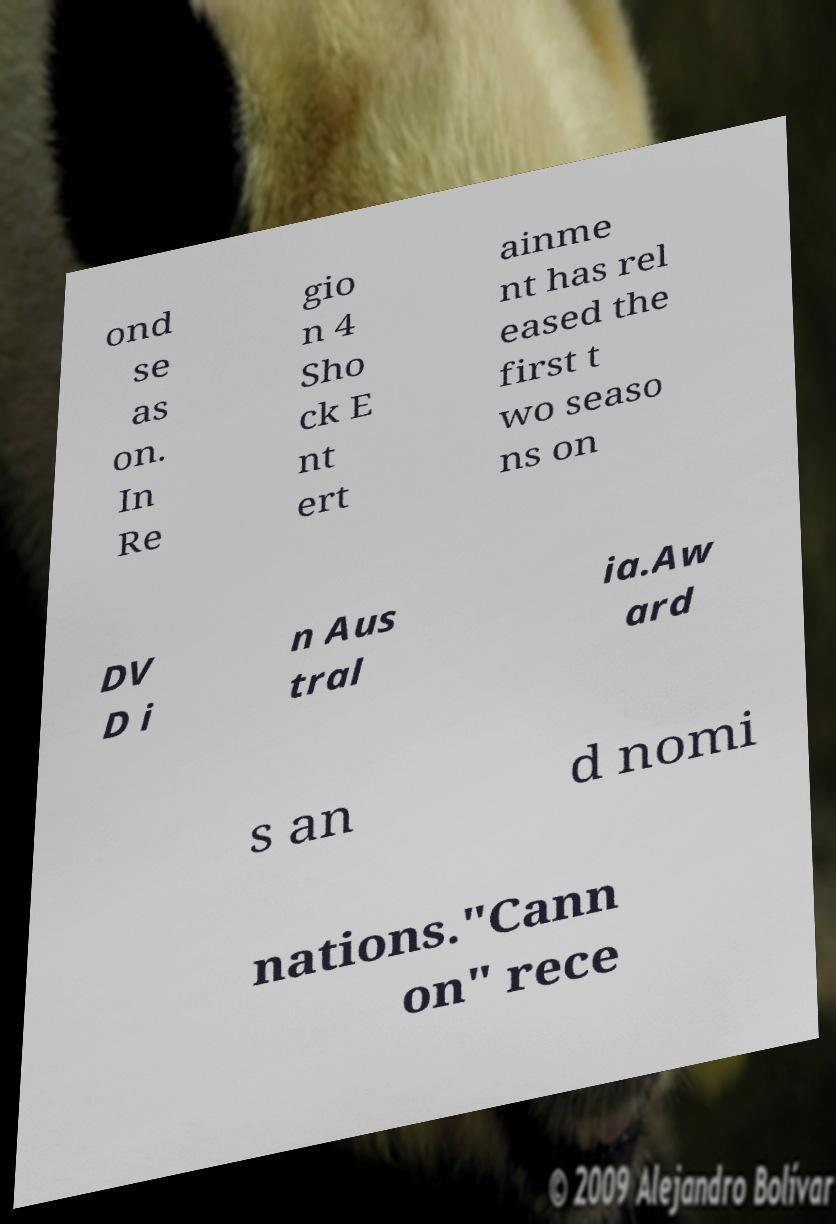Can you accurately transcribe the text from the provided image for me? ond se as on. In Re gio n 4 Sho ck E nt ert ainme nt has rel eased the first t wo seaso ns on DV D i n Aus tral ia.Aw ard s an d nomi nations."Cann on" rece 